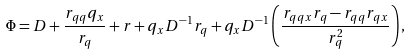<formula> <loc_0><loc_0><loc_500><loc_500>\Phi = D + \frac { r _ { q q } q _ { x } } { r _ { q } } + r + q _ { x } D ^ { - 1 } r _ { q } + q _ { x } D ^ { - 1 } \left ( \frac { r _ { q q x } r _ { q } - r _ { q q } r _ { q x } } { r _ { q } ^ { 2 } } \right ) ,</formula> 